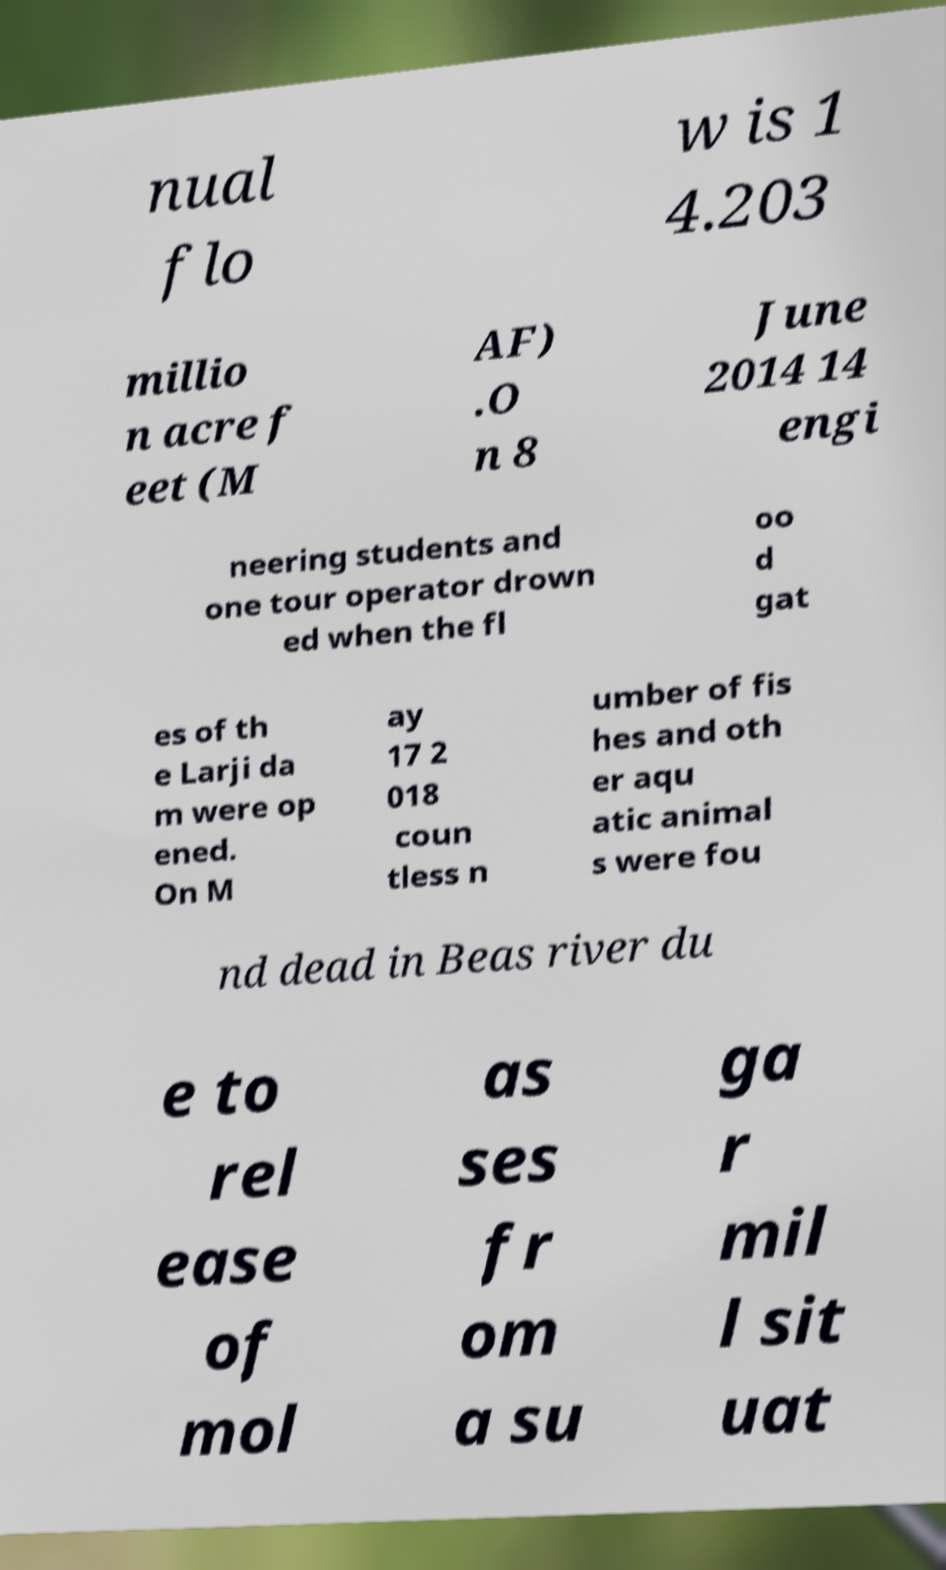Can you read and provide the text displayed in the image?This photo seems to have some interesting text. Can you extract and type it out for me? nual flo w is 1 4.203 millio n acre f eet (M AF) .O n 8 June 2014 14 engi neering students and one tour operator drown ed when the fl oo d gat es of th e Larji da m were op ened. On M ay 17 2 018 coun tless n umber of fis hes and oth er aqu atic animal s were fou nd dead in Beas river du e to rel ease of mol as ses fr om a su ga r mil l sit uat 